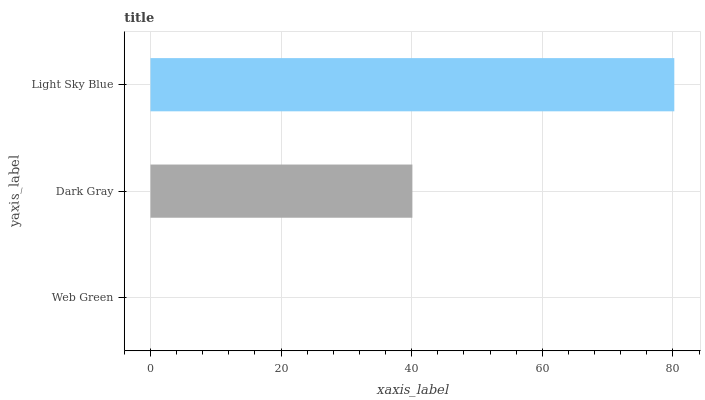Is Web Green the minimum?
Answer yes or no. Yes. Is Light Sky Blue the maximum?
Answer yes or no. Yes. Is Dark Gray the minimum?
Answer yes or no. No. Is Dark Gray the maximum?
Answer yes or no. No. Is Dark Gray greater than Web Green?
Answer yes or no. Yes. Is Web Green less than Dark Gray?
Answer yes or no. Yes. Is Web Green greater than Dark Gray?
Answer yes or no. No. Is Dark Gray less than Web Green?
Answer yes or no. No. Is Dark Gray the high median?
Answer yes or no. Yes. Is Dark Gray the low median?
Answer yes or no. Yes. Is Web Green the high median?
Answer yes or no. No. Is Web Green the low median?
Answer yes or no. No. 